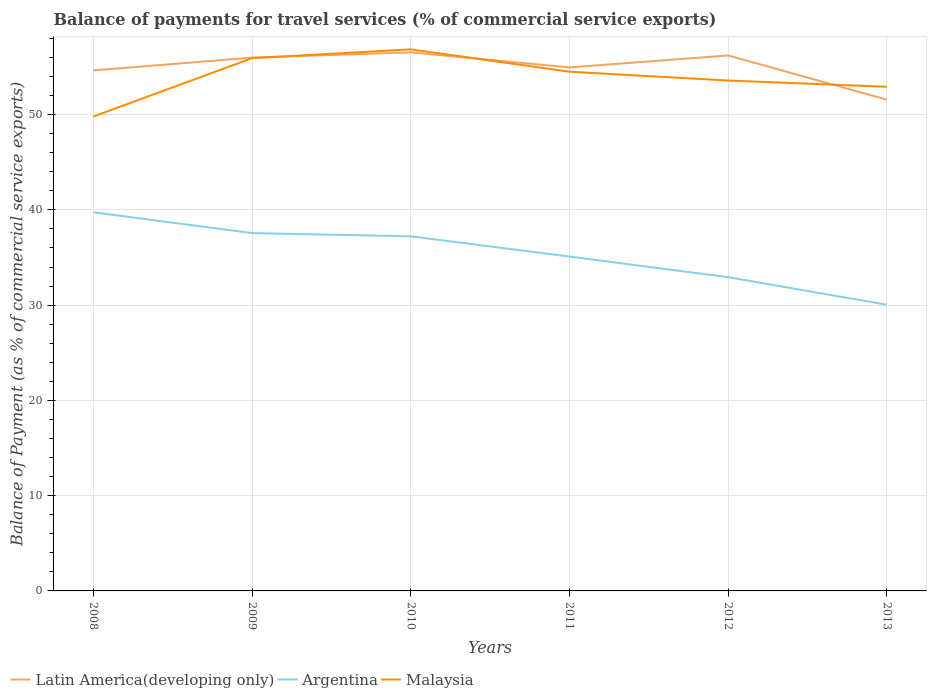Is the number of lines equal to the number of legend labels?
Ensure brevity in your answer.  Yes. Across all years, what is the maximum balance of payments for travel services in Argentina?
Your answer should be very brief. 30.04. What is the total balance of payments for travel services in Argentina in the graph?
Ensure brevity in your answer.  2.18. What is the difference between the highest and the second highest balance of payments for travel services in Argentina?
Your answer should be compact. 9.7. Is the balance of payments for travel services in Malaysia strictly greater than the balance of payments for travel services in Argentina over the years?
Keep it short and to the point. No. How many years are there in the graph?
Ensure brevity in your answer.  6. Are the values on the major ticks of Y-axis written in scientific E-notation?
Your response must be concise. No. Does the graph contain grids?
Your response must be concise. Yes. How many legend labels are there?
Keep it short and to the point. 3. What is the title of the graph?
Your response must be concise. Balance of payments for travel services (% of commercial service exports). Does "Vanuatu" appear as one of the legend labels in the graph?
Your answer should be compact. No. What is the label or title of the X-axis?
Your answer should be very brief. Years. What is the label or title of the Y-axis?
Make the answer very short. Balance of Payment (as % of commercial service exports). What is the Balance of Payment (as % of commercial service exports) in Latin America(developing only) in 2008?
Your answer should be compact. 54.63. What is the Balance of Payment (as % of commercial service exports) of Argentina in 2008?
Keep it short and to the point. 39.74. What is the Balance of Payment (as % of commercial service exports) of Malaysia in 2008?
Offer a terse response. 49.79. What is the Balance of Payment (as % of commercial service exports) in Latin America(developing only) in 2009?
Your answer should be compact. 55.98. What is the Balance of Payment (as % of commercial service exports) of Argentina in 2009?
Your answer should be compact. 37.56. What is the Balance of Payment (as % of commercial service exports) in Malaysia in 2009?
Ensure brevity in your answer.  55.92. What is the Balance of Payment (as % of commercial service exports) in Latin America(developing only) in 2010?
Your response must be concise. 56.53. What is the Balance of Payment (as % of commercial service exports) in Argentina in 2010?
Your answer should be very brief. 37.22. What is the Balance of Payment (as % of commercial service exports) in Malaysia in 2010?
Offer a very short reply. 56.85. What is the Balance of Payment (as % of commercial service exports) in Latin America(developing only) in 2011?
Give a very brief answer. 54.95. What is the Balance of Payment (as % of commercial service exports) of Argentina in 2011?
Provide a succinct answer. 35.1. What is the Balance of Payment (as % of commercial service exports) in Malaysia in 2011?
Offer a very short reply. 54.5. What is the Balance of Payment (as % of commercial service exports) of Latin America(developing only) in 2012?
Offer a very short reply. 56.2. What is the Balance of Payment (as % of commercial service exports) of Argentina in 2012?
Your answer should be very brief. 32.93. What is the Balance of Payment (as % of commercial service exports) of Malaysia in 2012?
Make the answer very short. 53.57. What is the Balance of Payment (as % of commercial service exports) of Latin America(developing only) in 2013?
Offer a very short reply. 51.57. What is the Balance of Payment (as % of commercial service exports) in Argentina in 2013?
Provide a short and direct response. 30.04. What is the Balance of Payment (as % of commercial service exports) in Malaysia in 2013?
Your response must be concise. 52.92. Across all years, what is the maximum Balance of Payment (as % of commercial service exports) of Latin America(developing only)?
Provide a short and direct response. 56.53. Across all years, what is the maximum Balance of Payment (as % of commercial service exports) in Argentina?
Give a very brief answer. 39.74. Across all years, what is the maximum Balance of Payment (as % of commercial service exports) in Malaysia?
Provide a succinct answer. 56.85. Across all years, what is the minimum Balance of Payment (as % of commercial service exports) of Latin America(developing only)?
Offer a terse response. 51.57. Across all years, what is the minimum Balance of Payment (as % of commercial service exports) of Argentina?
Ensure brevity in your answer.  30.04. Across all years, what is the minimum Balance of Payment (as % of commercial service exports) of Malaysia?
Your answer should be very brief. 49.79. What is the total Balance of Payment (as % of commercial service exports) of Latin America(developing only) in the graph?
Your answer should be compact. 329.87. What is the total Balance of Payment (as % of commercial service exports) in Argentina in the graph?
Provide a short and direct response. 212.59. What is the total Balance of Payment (as % of commercial service exports) in Malaysia in the graph?
Give a very brief answer. 323.55. What is the difference between the Balance of Payment (as % of commercial service exports) in Latin America(developing only) in 2008 and that in 2009?
Your answer should be very brief. -1.35. What is the difference between the Balance of Payment (as % of commercial service exports) in Argentina in 2008 and that in 2009?
Ensure brevity in your answer.  2.18. What is the difference between the Balance of Payment (as % of commercial service exports) in Malaysia in 2008 and that in 2009?
Provide a short and direct response. -6.13. What is the difference between the Balance of Payment (as % of commercial service exports) of Latin America(developing only) in 2008 and that in 2010?
Your response must be concise. -1.89. What is the difference between the Balance of Payment (as % of commercial service exports) in Argentina in 2008 and that in 2010?
Make the answer very short. 2.52. What is the difference between the Balance of Payment (as % of commercial service exports) of Malaysia in 2008 and that in 2010?
Your response must be concise. -7.05. What is the difference between the Balance of Payment (as % of commercial service exports) of Latin America(developing only) in 2008 and that in 2011?
Ensure brevity in your answer.  -0.32. What is the difference between the Balance of Payment (as % of commercial service exports) in Argentina in 2008 and that in 2011?
Your answer should be compact. 4.64. What is the difference between the Balance of Payment (as % of commercial service exports) in Malaysia in 2008 and that in 2011?
Your response must be concise. -4.71. What is the difference between the Balance of Payment (as % of commercial service exports) of Latin America(developing only) in 2008 and that in 2012?
Provide a short and direct response. -1.57. What is the difference between the Balance of Payment (as % of commercial service exports) of Argentina in 2008 and that in 2012?
Keep it short and to the point. 6.81. What is the difference between the Balance of Payment (as % of commercial service exports) of Malaysia in 2008 and that in 2012?
Keep it short and to the point. -3.78. What is the difference between the Balance of Payment (as % of commercial service exports) of Latin America(developing only) in 2008 and that in 2013?
Provide a short and direct response. 3.07. What is the difference between the Balance of Payment (as % of commercial service exports) in Argentina in 2008 and that in 2013?
Your answer should be very brief. 9.7. What is the difference between the Balance of Payment (as % of commercial service exports) in Malaysia in 2008 and that in 2013?
Make the answer very short. -3.13. What is the difference between the Balance of Payment (as % of commercial service exports) of Latin America(developing only) in 2009 and that in 2010?
Your answer should be compact. -0.55. What is the difference between the Balance of Payment (as % of commercial service exports) in Argentina in 2009 and that in 2010?
Give a very brief answer. 0.34. What is the difference between the Balance of Payment (as % of commercial service exports) in Malaysia in 2009 and that in 2010?
Provide a short and direct response. -0.93. What is the difference between the Balance of Payment (as % of commercial service exports) of Latin America(developing only) in 2009 and that in 2011?
Give a very brief answer. 1.03. What is the difference between the Balance of Payment (as % of commercial service exports) in Argentina in 2009 and that in 2011?
Provide a succinct answer. 2.46. What is the difference between the Balance of Payment (as % of commercial service exports) of Malaysia in 2009 and that in 2011?
Your answer should be very brief. 1.42. What is the difference between the Balance of Payment (as % of commercial service exports) of Latin America(developing only) in 2009 and that in 2012?
Offer a terse response. -0.22. What is the difference between the Balance of Payment (as % of commercial service exports) of Argentina in 2009 and that in 2012?
Ensure brevity in your answer.  4.63. What is the difference between the Balance of Payment (as % of commercial service exports) in Malaysia in 2009 and that in 2012?
Ensure brevity in your answer.  2.35. What is the difference between the Balance of Payment (as % of commercial service exports) in Latin America(developing only) in 2009 and that in 2013?
Your answer should be very brief. 4.42. What is the difference between the Balance of Payment (as % of commercial service exports) of Argentina in 2009 and that in 2013?
Provide a short and direct response. 7.52. What is the difference between the Balance of Payment (as % of commercial service exports) of Malaysia in 2009 and that in 2013?
Offer a very short reply. 3. What is the difference between the Balance of Payment (as % of commercial service exports) of Latin America(developing only) in 2010 and that in 2011?
Your answer should be very brief. 1.58. What is the difference between the Balance of Payment (as % of commercial service exports) of Argentina in 2010 and that in 2011?
Your answer should be very brief. 2.12. What is the difference between the Balance of Payment (as % of commercial service exports) of Malaysia in 2010 and that in 2011?
Your answer should be very brief. 2.35. What is the difference between the Balance of Payment (as % of commercial service exports) of Latin America(developing only) in 2010 and that in 2012?
Give a very brief answer. 0.32. What is the difference between the Balance of Payment (as % of commercial service exports) of Argentina in 2010 and that in 2012?
Make the answer very short. 4.29. What is the difference between the Balance of Payment (as % of commercial service exports) of Malaysia in 2010 and that in 2012?
Ensure brevity in your answer.  3.27. What is the difference between the Balance of Payment (as % of commercial service exports) of Latin America(developing only) in 2010 and that in 2013?
Give a very brief answer. 4.96. What is the difference between the Balance of Payment (as % of commercial service exports) of Argentina in 2010 and that in 2013?
Keep it short and to the point. 7.18. What is the difference between the Balance of Payment (as % of commercial service exports) of Malaysia in 2010 and that in 2013?
Give a very brief answer. 3.93. What is the difference between the Balance of Payment (as % of commercial service exports) of Latin America(developing only) in 2011 and that in 2012?
Offer a very short reply. -1.25. What is the difference between the Balance of Payment (as % of commercial service exports) in Argentina in 2011 and that in 2012?
Keep it short and to the point. 2.17. What is the difference between the Balance of Payment (as % of commercial service exports) in Malaysia in 2011 and that in 2012?
Ensure brevity in your answer.  0.93. What is the difference between the Balance of Payment (as % of commercial service exports) in Latin America(developing only) in 2011 and that in 2013?
Offer a terse response. 3.39. What is the difference between the Balance of Payment (as % of commercial service exports) in Argentina in 2011 and that in 2013?
Provide a short and direct response. 5.06. What is the difference between the Balance of Payment (as % of commercial service exports) in Malaysia in 2011 and that in 2013?
Keep it short and to the point. 1.58. What is the difference between the Balance of Payment (as % of commercial service exports) in Latin America(developing only) in 2012 and that in 2013?
Your response must be concise. 4.64. What is the difference between the Balance of Payment (as % of commercial service exports) in Argentina in 2012 and that in 2013?
Offer a terse response. 2.89. What is the difference between the Balance of Payment (as % of commercial service exports) in Malaysia in 2012 and that in 2013?
Your answer should be compact. 0.65. What is the difference between the Balance of Payment (as % of commercial service exports) in Latin America(developing only) in 2008 and the Balance of Payment (as % of commercial service exports) in Argentina in 2009?
Make the answer very short. 17.07. What is the difference between the Balance of Payment (as % of commercial service exports) in Latin America(developing only) in 2008 and the Balance of Payment (as % of commercial service exports) in Malaysia in 2009?
Give a very brief answer. -1.29. What is the difference between the Balance of Payment (as % of commercial service exports) of Argentina in 2008 and the Balance of Payment (as % of commercial service exports) of Malaysia in 2009?
Offer a very short reply. -16.18. What is the difference between the Balance of Payment (as % of commercial service exports) of Latin America(developing only) in 2008 and the Balance of Payment (as % of commercial service exports) of Argentina in 2010?
Ensure brevity in your answer.  17.41. What is the difference between the Balance of Payment (as % of commercial service exports) of Latin America(developing only) in 2008 and the Balance of Payment (as % of commercial service exports) of Malaysia in 2010?
Your answer should be very brief. -2.21. What is the difference between the Balance of Payment (as % of commercial service exports) of Argentina in 2008 and the Balance of Payment (as % of commercial service exports) of Malaysia in 2010?
Offer a very short reply. -17.11. What is the difference between the Balance of Payment (as % of commercial service exports) in Latin America(developing only) in 2008 and the Balance of Payment (as % of commercial service exports) in Argentina in 2011?
Give a very brief answer. 19.54. What is the difference between the Balance of Payment (as % of commercial service exports) of Latin America(developing only) in 2008 and the Balance of Payment (as % of commercial service exports) of Malaysia in 2011?
Keep it short and to the point. 0.13. What is the difference between the Balance of Payment (as % of commercial service exports) in Argentina in 2008 and the Balance of Payment (as % of commercial service exports) in Malaysia in 2011?
Make the answer very short. -14.76. What is the difference between the Balance of Payment (as % of commercial service exports) in Latin America(developing only) in 2008 and the Balance of Payment (as % of commercial service exports) in Argentina in 2012?
Provide a succinct answer. 21.7. What is the difference between the Balance of Payment (as % of commercial service exports) in Latin America(developing only) in 2008 and the Balance of Payment (as % of commercial service exports) in Malaysia in 2012?
Provide a short and direct response. 1.06. What is the difference between the Balance of Payment (as % of commercial service exports) of Argentina in 2008 and the Balance of Payment (as % of commercial service exports) of Malaysia in 2012?
Offer a terse response. -13.83. What is the difference between the Balance of Payment (as % of commercial service exports) of Latin America(developing only) in 2008 and the Balance of Payment (as % of commercial service exports) of Argentina in 2013?
Ensure brevity in your answer.  24.6. What is the difference between the Balance of Payment (as % of commercial service exports) of Latin America(developing only) in 2008 and the Balance of Payment (as % of commercial service exports) of Malaysia in 2013?
Your answer should be very brief. 1.71. What is the difference between the Balance of Payment (as % of commercial service exports) of Argentina in 2008 and the Balance of Payment (as % of commercial service exports) of Malaysia in 2013?
Ensure brevity in your answer.  -13.18. What is the difference between the Balance of Payment (as % of commercial service exports) of Latin America(developing only) in 2009 and the Balance of Payment (as % of commercial service exports) of Argentina in 2010?
Your answer should be very brief. 18.76. What is the difference between the Balance of Payment (as % of commercial service exports) of Latin America(developing only) in 2009 and the Balance of Payment (as % of commercial service exports) of Malaysia in 2010?
Ensure brevity in your answer.  -0.87. What is the difference between the Balance of Payment (as % of commercial service exports) in Argentina in 2009 and the Balance of Payment (as % of commercial service exports) in Malaysia in 2010?
Your answer should be compact. -19.29. What is the difference between the Balance of Payment (as % of commercial service exports) in Latin America(developing only) in 2009 and the Balance of Payment (as % of commercial service exports) in Argentina in 2011?
Give a very brief answer. 20.88. What is the difference between the Balance of Payment (as % of commercial service exports) in Latin America(developing only) in 2009 and the Balance of Payment (as % of commercial service exports) in Malaysia in 2011?
Offer a terse response. 1.48. What is the difference between the Balance of Payment (as % of commercial service exports) of Argentina in 2009 and the Balance of Payment (as % of commercial service exports) of Malaysia in 2011?
Offer a terse response. -16.94. What is the difference between the Balance of Payment (as % of commercial service exports) in Latin America(developing only) in 2009 and the Balance of Payment (as % of commercial service exports) in Argentina in 2012?
Give a very brief answer. 23.05. What is the difference between the Balance of Payment (as % of commercial service exports) of Latin America(developing only) in 2009 and the Balance of Payment (as % of commercial service exports) of Malaysia in 2012?
Provide a succinct answer. 2.41. What is the difference between the Balance of Payment (as % of commercial service exports) in Argentina in 2009 and the Balance of Payment (as % of commercial service exports) in Malaysia in 2012?
Provide a succinct answer. -16.01. What is the difference between the Balance of Payment (as % of commercial service exports) in Latin America(developing only) in 2009 and the Balance of Payment (as % of commercial service exports) in Argentina in 2013?
Offer a very short reply. 25.94. What is the difference between the Balance of Payment (as % of commercial service exports) in Latin America(developing only) in 2009 and the Balance of Payment (as % of commercial service exports) in Malaysia in 2013?
Your answer should be very brief. 3.06. What is the difference between the Balance of Payment (as % of commercial service exports) of Argentina in 2009 and the Balance of Payment (as % of commercial service exports) of Malaysia in 2013?
Offer a very short reply. -15.36. What is the difference between the Balance of Payment (as % of commercial service exports) in Latin America(developing only) in 2010 and the Balance of Payment (as % of commercial service exports) in Argentina in 2011?
Your answer should be compact. 21.43. What is the difference between the Balance of Payment (as % of commercial service exports) of Latin America(developing only) in 2010 and the Balance of Payment (as % of commercial service exports) of Malaysia in 2011?
Provide a succinct answer. 2.03. What is the difference between the Balance of Payment (as % of commercial service exports) of Argentina in 2010 and the Balance of Payment (as % of commercial service exports) of Malaysia in 2011?
Provide a succinct answer. -17.28. What is the difference between the Balance of Payment (as % of commercial service exports) in Latin America(developing only) in 2010 and the Balance of Payment (as % of commercial service exports) in Argentina in 2012?
Your answer should be very brief. 23.6. What is the difference between the Balance of Payment (as % of commercial service exports) in Latin America(developing only) in 2010 and the Balance of Payment (as % of commercial service exports) in Malaysia in 2012?
Make the answer very short. 2.95. What is the difference between the Balance of Payment (as % of commercial service exports) of Argentina in 2010 and the Balance of Payment (as % of commercial service exports) of Malaysia in 2012?
Keep it short and to the point. -16.35. What is the difference between the Balance of Payment (as % of commercial service exports) of Latin America(developing only) in 2010 and the Balance of Payment (as % of commercial service exports) of Argentina in 2013?
Give a very brief answer. 26.49. What is the difference between the Balance of Payment (as % of commercial service exports) in Latin America(developing only) in 2010 and the Balance of Payment (as % of commercial service exports) in Malaysia in 2013?
Keep it short and to the point. 3.61. What is the difference between the Balance of Payment (as % of commercial service exports) in Argentina in 2010 and the Balance of Payment (as % of commercial service exports) in Malaysia in 2013?
Make the answer very short. -15.7. What is the difference between the Balance of Payment (as % of commercial service exports) of Latin America(developing only) in 2011 and the Balance of Payment (as % of commercial service exports) of Argentina in 2012?
Offer a terse response. 22.02. What is the difference between the Balance of Payment (as % of commercial service exports) of Latin America(developing only) in 2011 and the Balance of Payment (as % of commercial service exports) of Malaysia in 2012?
Offer a very short reply. 1.38. What is the difference between the Balance of Payment (as % of commercial service exports) in Argentina in 2011 and the Balance of Payment (as % of commercial service exports) in Malaysia in 2012?
Offer a terse response. -18.47. What is the difference between the Balance of Payment (as % of commercial service exports) of Latin America(developing only) in 2011 and the Balance of Payment (as % of commercial service exports) of Argentina in 2013?
Provide a short and direct response. 24.91. What is the difference between the Balance of Payment (as % of commercial service exports) in Latin America(developing only) in 2011 and the Balance of Payment (as % of commercial service exports) in Malaysia in 2013?
Keep it short and to the point. 2.03. What is the difference between the Balance of Payment (as % of commercial service exports) of Argentina in 2011 and the Balance of Payment (as % of commercial service exports) of Malaysia in 2013?
Make the answer very short. -17.82. What is the difference between the Balance of Payment (as % of commercial service exports) of Latin America(developing only) in 2012 and the Balance of Payment (as % of commercial service exports) of Argentina in 2013?
Offer a very short reply. 26.17. What is the difference between the Balance of Payment (as % of commercial service exports) in Latin America(developing only) in 2012 and the Balance of Payment (as % of commercial service exports) in Malaysia in 2013?
Make the answer very short. 3.28. What is the difference between the Balance of Payment (as % of commercial service exports) of Argentina in 2012 and the Balance of Payment (as % of commercial service exports) of Malaysia in 2013?
Your answer should be compact. -19.99. What is the average Balance of Payment (as % of commercial service exports) in Latin America(developing only) per year?
Give a very brief answer. 54.98. What is the average Balance of Payment (as % of commercial service exports) of Argentina per year?
Ensure brevity in your answer.  35.43. What is the average Balance of Payment (as % of commercial service exports) of Malaysia per year?
Offer a terse response. 53.93. In the year 2008, what is the difference between the Balance of Payment (as % of commercial service exports) of Latin America(developing only) and Balance of Payment (as % of commercial service exports) of Argentina?
Your response must be concise. 14.89. In the year 2008, what is the difference between the Balance of Payment (as % of commercial service exports) of Latin America(developing only) and Balance of Payment (as % of commercial service exports) of Malaysia?
Your answer should be compact. 4.84. In the year 2008, what is the difference between the Balance of Payment (as % of commercial service exports) of Argentina and Balance of Payment (as % of commercial service exports) of Malaysia?
Your answer should be compact. -10.05. In the year 2009, what is the difference between the Balance of Payment (as % of commercial service exports) in Latin America(developing only) and Balance of Payment (as % of commercial service exports) in Argentina?
Offer a terse response. 18.42. In the year 2009, what is the difference between the Balance of Payment (as % of commercial service exports) of Latin America(developing only) and Balance of Payment (as % of commercial service exports) of Malaysia?
Offer a terse response. 0.06. In the year 2009, what is the difference between the Balance of Payment (as % of commercial service exports) in Argentina and Balance of Payment (as % of commercial service exports) in Malaysia?
Provide a succinct answer. -18.36. In the year 2010, what is the difference between the Balance of Payment (as % of commercial service exports) of Latin America(developing only) and Balance of Payment (as % of commercial service exports) of Argentina?
Offer a terse response. 19.31. In the year 2010, what is the difference between the Balance of Payment (as % of commercial service exports) in Latin America(developing only) and Balance of Payment (as % of commercial service exports) in Malaysia?
Your answer should be very brief. -0.32. In the year 2010, what is the difference between the Balance of Payment (as % of commercial service exports) of Argentina and Balance of Payment (as % of commercial service exports) of Malaysia?
Make the answer very short. -19.63. In the year 2011, what is the difference between the Balance of Payment (as % of commercial service exports) of Latin America(developing only) and Balance of Payment (as % of commercial service exports) of Argentina?
Your response must be concise. 19.85. In the year 2011, what is the difference between the Balance of Payment (as % of commercial service exports) of Latin America(developing only) and Balance of Payment (as % of commercial service exports) of Malaysia?
Your answer should be very brief. 0.45. In the year 2011, what is the difference between the Balance of Payment (as % of commercial service exports) in Argentina and Balance of Payment (as % of commercial service exports) in Malaysia?
Provide a succinct answer. -19.4. In the year 2012, what is the difference between the Balance of Payment (as % of commercial service exports) of Latin America(developing only) and Balance of Payment (as % of commercial service exports) of Argentina?
Keep it short and to the point. 23.27. In the year 2012, what is the difference between the Balance of Payment (as % of commercial service exports) of Latin America(developing only) and Balance of Payment (as % of commercial service exports) of Malaysia?
Your answer should be very brief. 2.63. In the year 2012, what is the difference between the Balance of Payment (as % of commercial service exports) in Argentina and Balance of Payment (as % of commercial service exports) in Malaysia?
Your answer should be very brief. -20.64. In the year 2013, what is the difference between the Balance of Payment (as % of commercial service exports) in Latin America(developing only) and Balance of Payment (as % of commercial service exports) in Argentina?
Your answer should be very brief. 21.53. In the year 2013, what is the difference between the Balance of Payment (as % of commercial service exports) in Latin America(developing only) and Balance of Payment (as % of commercial service exports) in Malaysia?
Offer a very short reply. -1.35. In the year 2013, what is the difference between the Balance of Payment (as % of commercial service exports) in Argentina and Balance of Payment (as % of commercial service exports) in Malaysia?
Your answer should be compact. -22.88. What is the ratio of the Balance of Payment (as % of commercial service exports) in Latin America(developing only) in 2008 to that in 2009?
Provide a succinct answer. 0.98. What is the ratio of the Balance of Payment (as % of commercial service exports) in Argentina in 2008 to that in 2009?
Your answer should be compact. 1.06. What is the ratio of the Balance of Payment (as % of commercial service exports) in Malaysia in 2008 to that in 2009?
Make the answer very short. 0.89. What is the ratio of the Balance of Payment (as % of commercial service exports) of Latin America(developing only) in 2008 to that in 2010?
Make the answer very short. 0.97. What is the ratio of the Balance of Payment (as % of commercial service exports) in Argentina in 2008 to that in 2010?
Your response must be concise. 1.07. What is the ratio of the Balance of Payment (as % of commercial service exports) in Malaysia in 2008 to that in 2010?
Give a very brief answer. 0.88. What is the ratio of the Balance of Payment (as % of commercial service exports) of Latin America(developing only) in 2008 to that in 2011?
Keep it short and to the point. 0.99. What is the ratio of the Balance of Payment (as % of commercial service exports) of Argentina in 2008 to that in 2011?
Provide a succinct answer. 1.13. What is the ratio of the Balance of Payment (as % of commercial service exports) in Malaysia in 2008 to that in 2011?
Ensure brevity in your answer.  0.91. What is the ratio of the Balance of Payment (as % of commercial service exports) in Latin America(developing only) in 2008 to that in 2012?
Your answer should be very brief. 0.97. What is the ratio of the Balance of Payment (as % of commercial service exports) in Argentina in 2008 to that in 2012?
Your answer should be very brief. 1.21. What is the ratio of the Balance of Payment (as % of commercial service exports) in Malaysia in 2008 to that in 2012?
Keep it short and to the point. 0.93. What is the ratio of the Balance of Payment (as % of commercial service exports) in Latin America(developing only) in 2008 to that in 2013?
Provide a succinct answer. 1.06. What is the ratio of the Balance of Payment (as % of commercial service exports) of Argentina in 2008 to that in 2013?
Ensure brevity in your answer.  1.32. What is the ratio of the Balance of Payment (as % of commercial service exports) of Malaysia in 2008 to that in 2013?
Ensure brevity in your answer.  0.94. What is the ratio of the Balance of Payment (as % of commercial service exports) in Latin America(developing only) in 2009 to that in 2010?
Offer a terse response. 0.99. What is the ratio of the Balance of Payment (as % of commercial service exports) of Argentina in 2009 to that in 2010?
Make the answer very short. 1.01. What is the ratio of the Balance of Payment (as % of commercial service exports) in Malaysia in 2009 to that in 2010?
Your response must be concise. 0.98. What is the ratio of the Balance of Payment (as % of commercial service exports) of Latin America(developing only) in 2009 to that in 2011?
Keep it short and to the point. 1.02. What is the ratio of the Balance of Payment (as % of commercial service exports) in Argentina in 2009 to that in 2011?
Provide a succinct answer. 1.07. What is the ratio of the Balance of Payment (as % of commercial service exports) of Malaysia in 2009 to that in 2011?
Make the answer very short. 1.03. What is the ratio of the Balance of Payment (as % of commercial service exports) in Latin America(developing only) in 2009 to that in 2012?
Provide a short and direct response. 1. What is the ratio of the Balance of Payment (as % of commercial service exports) in Argentina in 2009 to that in 2012?
Keep it short and to the point. 1.14. What is the ratio of the Balance of Payment (as % of commercial service exports) in Malaysia in 2009 to that in 2012?
Give a very brief answer. 1.04. What is the ratio of the Balance of Payment (as % of commercial service exports) of Latin America(developing only) in 2009 to that in 2013?
Make the answer very short. 1.09. What is the ratio of the Balance of Payment (as % of commercial service exports) in Argentina in 2009 to that in 2013?
Give a very brief answer. 1.25. What is the ratio of the Balance of Payment (as % of commercial service exports) of Malaysia in 2009 to that in 2013?
Provide a short and direct response. 1.06. What is the ratio of the Balance of Payment (as % of commercial service exports) in Latin America(developing only) in 2010 to that in 2011?
Keep it short and to the point. 1.03. What is the ratio of the Balance of Payment (as % of commercial service exports) in Argentina in 2010 to that in 2011?
Keep it short and to the point. 1.06. What is the ratio of the Balance of Payment (as % of commercial service exports) in Malaysia in 2010 to that in 2011?
Give a very brief answer. 1.04. What is the ratio of the Balance of Payment (as % of commercial service exports) in Argentina in 2010 to that in 2012?
Make the answer very short. 1.13. What is the ratio of the Balance of Payment (as % of commercial service exports) of Malaysia in 2010 to that in 2012?
Offer a very short reply. 1.06. What is the ratio of the Balance of Payment (as % of commercial service exports) of Latin America(developing only) in 2010 to that in 2013?
Offer a terse response. 1.1. What is the ratio of the Balance of Payment (as % of commercial service exports) in Argentina in 2010 to that in 2013?
Keep it short and to the point. 1.24. What is the ratio of the Balance of Payment (as % of commercial service exports) of Malaysia in 2010 to that in 2013?
Keep it short and to the point. 1.07. What is the ratio of the Balance of Payment (as % of commercial service exports) in Latin America(developing only) in 2011 to that in 2012?
Keep it short and to the point. 0.98. What is the ratio of the Balance of Payment (as % of commercial service exports) of Argentina in 2011 to that in 2012?
Keep it short and to the point. 1.07. What is the ratio of the Balance of Payment (as % of commercial service exports) of Malaysia in 2011 to that in 2012?
Make the answer very short. 1.02. What is the ratio of the Balance of Payment (as % of commercial service exports) of Latin America(developing only) in 2011 to that in 2013?
Provide a succinct answer. 1.07. What is the ratio of the Balance of Payment (as % of commercial service exports) in Argentina in 2011 to that in 2013?
Your answer should be compact. 1.17. What is the ratio of the Balance of Payment (as % of commercial service exports) in Malaysia in 2011 to that in 2013?
Ensure brevity in your answer.  1.03. What is the ratio of the Balance of Payment (as % of commercial service exports) of Latin America(developing only) in 2012 to that in 2013?
Give a very brief answer. 1.09. What is the ratio of the Balance of Payment (as % of commercial service exports) in Argentina in 2012 to that in 2013?
Your response must be concise. 1.1. What is the ratio of the Balance of Payment (as % of commercial service exports) in Malaysia in 2012 to that in 2013?
Your answer should be very brief. 1.01. What is the difference between the highest and the second highest Balance of Payment (as % of commercial service exports) of Latin America(developing only)?
Keep it short and to the point. 0.32. What is the difference between the highest and the second highest Balance of Payment (as % of commercial service exports) in Argentina?
Your answer should be compact. 2.18. What is the difference between the highest and the second highest Balance of Payment (as % of commercial service exports) of Malaysia?
Offer a terse response. 0.93. What is the difference between the highest and the lowest Balance of Payment (as % of commercial service exports) in Latin America(developing only)?
Your answer should be compact. 4.96. What is the difference between the highest and the lowest Balance of Payment (as % of commercial service exports) of Argentina?
Provide a succinct answer. 9.7. What is the difference between the highest and the lowest Balance of Payment (as % of commercial service exports) in Malaysia?
Make the answer very short. 7.05. 